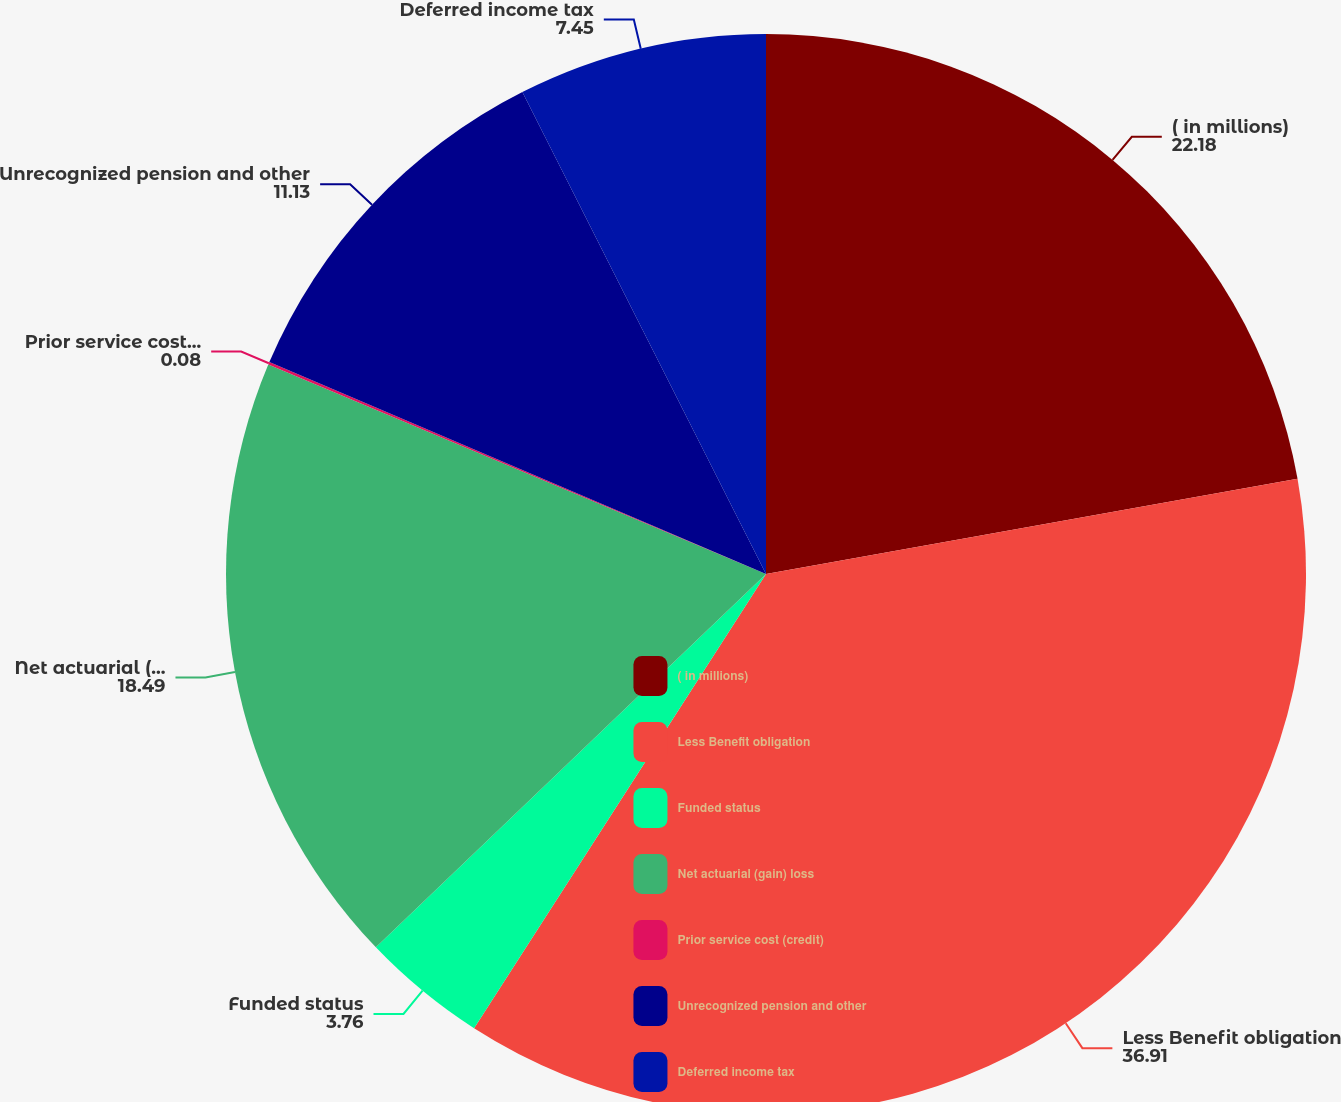<chart> <loc_0><loc_0><loc_500><loc_500><pie_chart><fcel>( in millions)<fcel>Less Benefit obligation<fcel>Funded status<fcel>Net actuarial (gain) loss<fcel>Prior service cost (credit)<fcel>Unrecognized pension and other<fcel>Deferred income tax<nl><fcel>22.18%<fcel>36.91%<fcel>3.76%<fcel>18.49%<fcel>0.08%<fcel>11.13%<fcel>7.45%<nl></chart> 